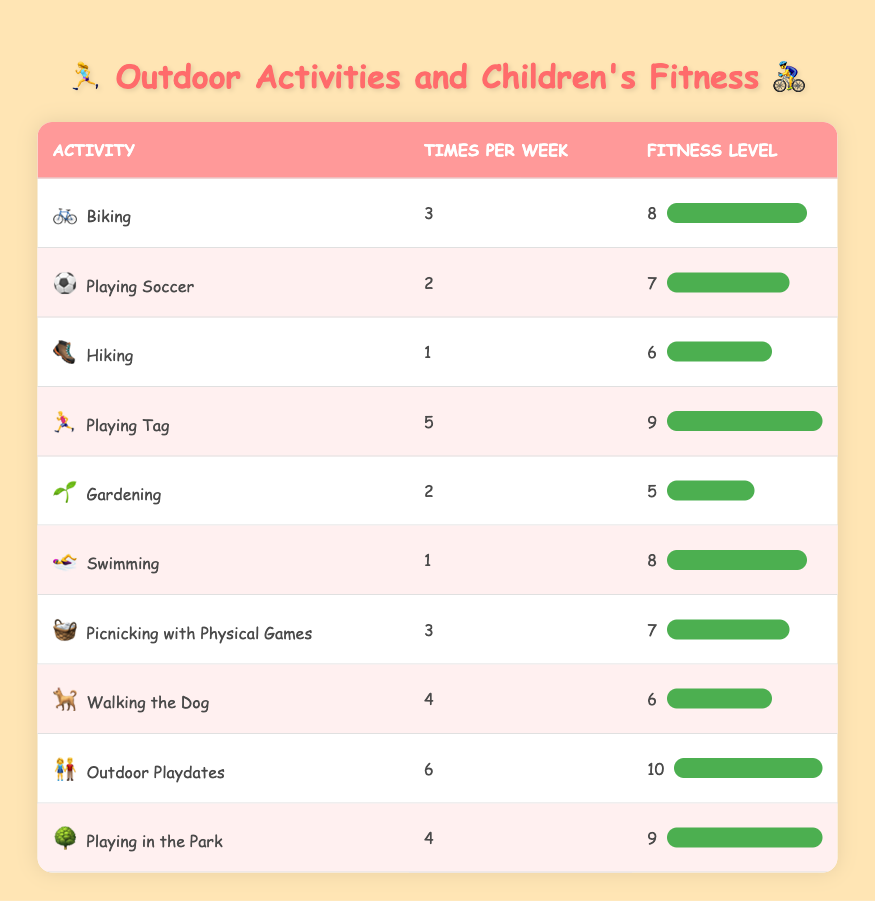What is the fitness level for Playing Tag? The fitness level for Playing Tag is indicated in the "Fitness Level" column next to the activity. It shows a fitness level of 9.
Answer: 9 How many times per week do the children do Gardening? The frequency of Gardening is listed as 2 times per week in the "Times per Week" column for that activity.
Answer: 2 Which activity has the highest fitness level? The activities listed in the table show that the highest fitness level of 10 corresponds to Outdoor Playdates.
Answer: Outdoor Playdates Are there any activities performed more than four times per week? By reviewing the "Times per Week" column, we find that the activities of Playing Tag (5), Outdoor Playdates (6), and Playing in the Park (4) fit this criterion.
Answer: Yes What is the average fitness level for activities that occur 3 or more times per week? To find the average fitness level, we sum the fitness levels of Biking (8), Playing Tag (9), Picnicking with Physical Games (7), Outdoor Playdates (10), and Playing in the Park (9), which gives 8 + 9 + 7 + 10 + 9 = 43. There are 5 activities, so the average is 43/5 = 8.6.
Answer: 8.6 Which activity is performed the least often, and what is its fitness level? By looking at the "Times per Week" column, Hiking is performed the least, only 1 time per week, and its fitness level is 6.
Answer: Hiking, Fitness Level 6 Is Swimming performed more frequently than Playing Soccer? Swimming occurs 1 time per week, while Playing Soccer is performed 2 times per week, making Swimming less frequent than Playing Soccer.
Answer: No What is the total frequency of outdoor activities that focus on physical games? Activities that focus on physical games include Playing Tag (5), Picnicking with Physical Games (3), and Outdoor Playdates (6). Summing these gives 5 + 3 + 6 = 14 times per week.
Answer: 14 